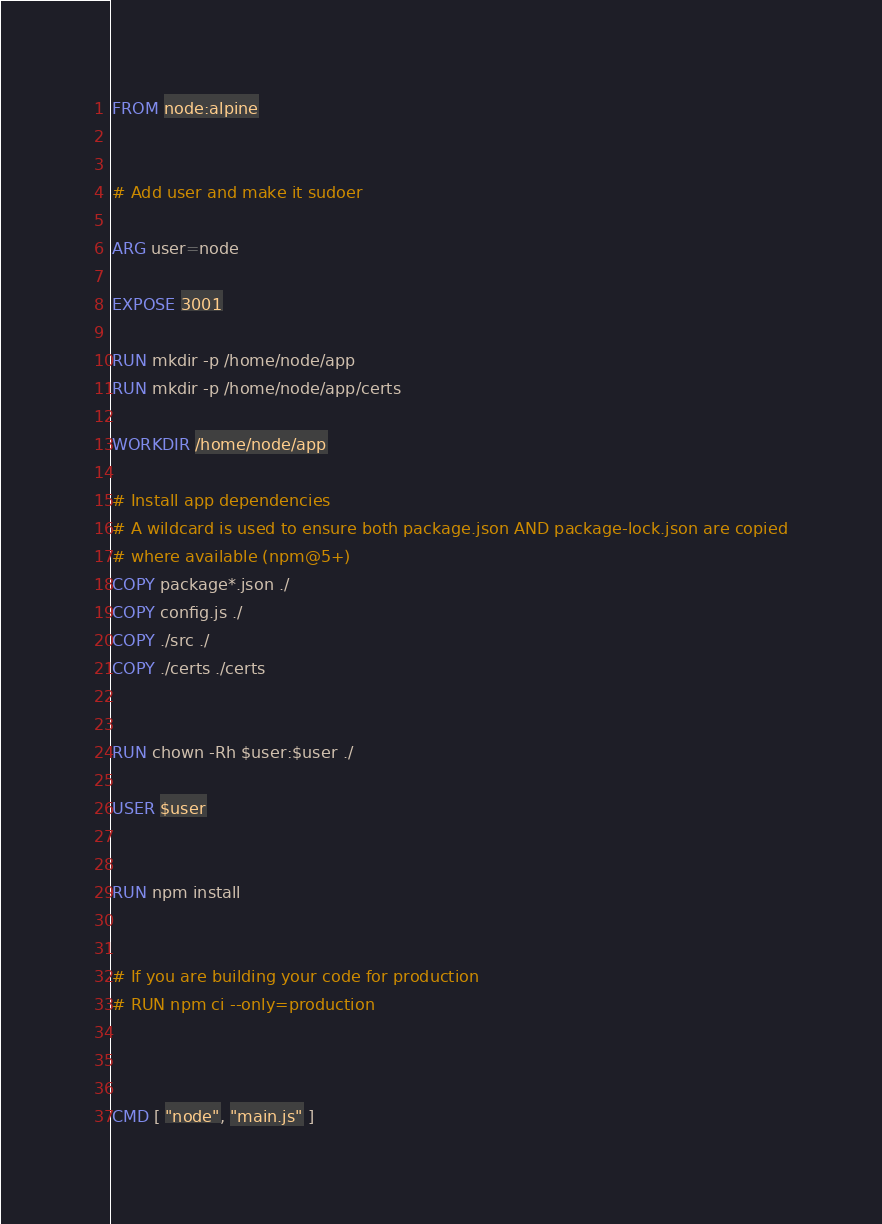Convert code to text. <code><loc_0><loc_0><loc_500><loc_500><_Dockerfile_>FROM node:alpine


# Add user and make it sudoer

ARG user=node

EXPOSE 3001

RUN mkdir -p /home/node/app
RUN mkdir -p /home/node/app/certs

WORKDIR /home/node/app

# Install app dependencies
# A wildcard is used to ensure both package.json AND package-lock.json are copied
# where available (npm@5+)
COPY package*.json ./
COPY config.js ./
COPY ./src ./
COPY ./certs ./certs


RUN chown -Rh $user:$user ./

USER $user


RUN npm install


# If you are building your code for production
# RUN npm ci --only=production



CMD [ "node", "main.js" ]</code> 